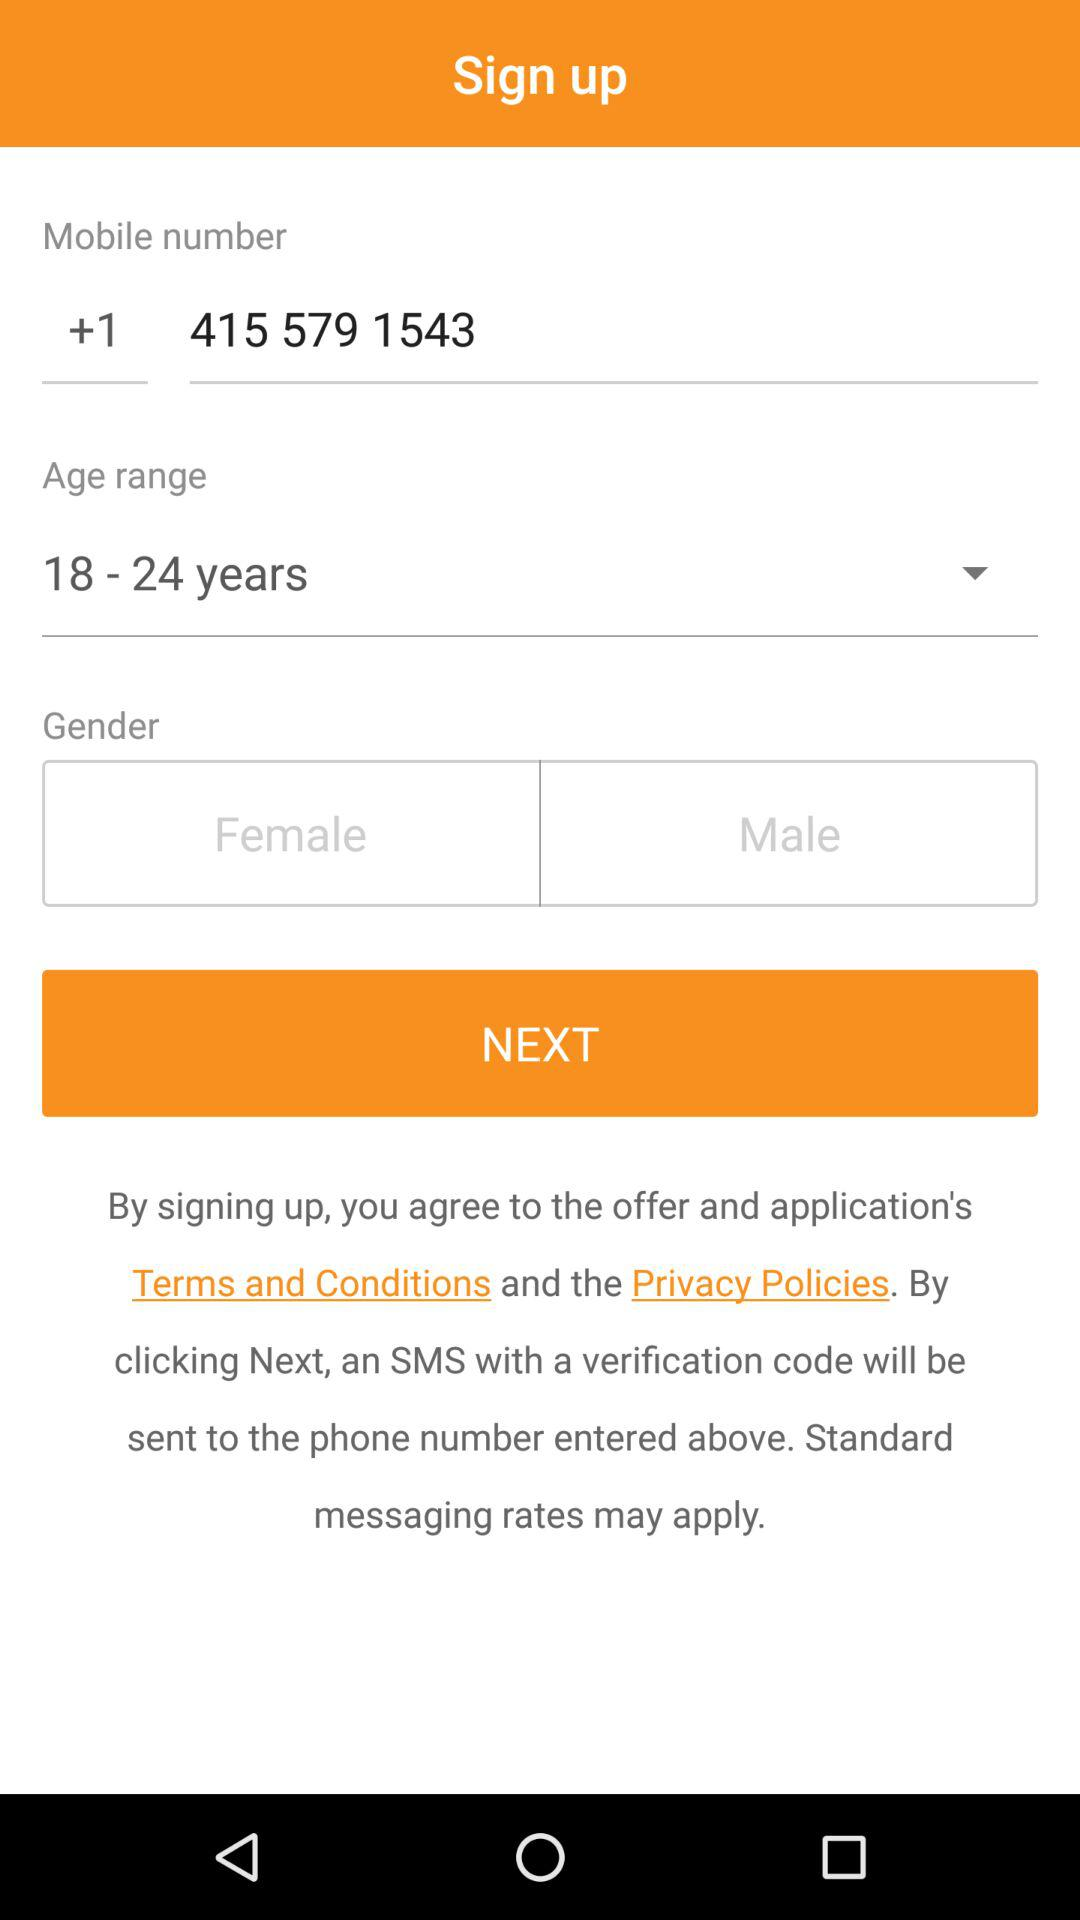What's the selected age range? The selected age range is 18–24 years. 